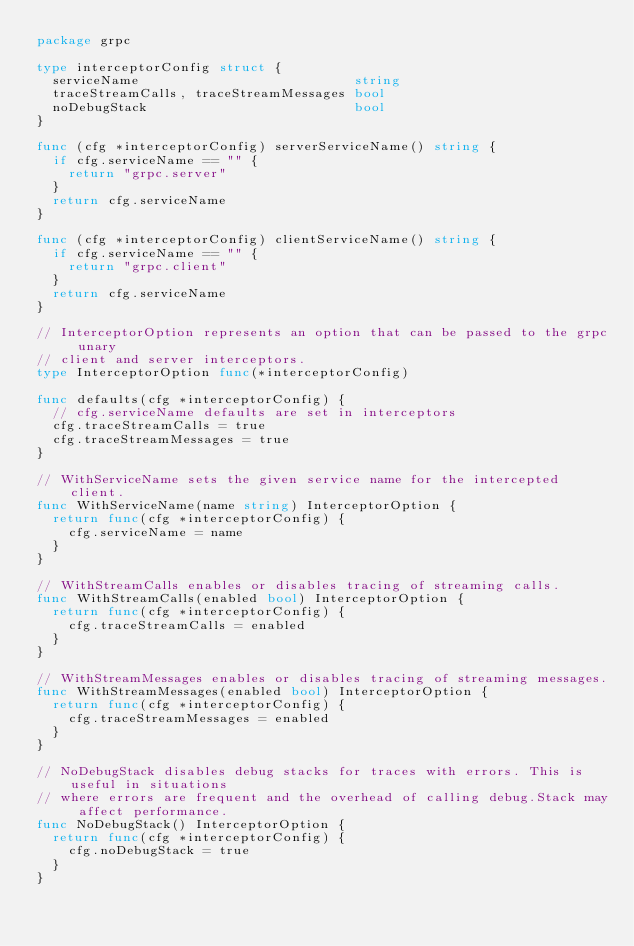<code> <loc_0><loc_0><loc_500><loc_500><_Go_>package grpc

type interceptorConfig struct {
	serviceName                           string
	traceStreamCalls, traceStreamMessages bool
	noDebugStack                          bool
}

func (cfg *interceptorConfig) serverServiceName() string {
	if cfg.serviceName == "" {
		return "grpc.server"
	}
	return cfg.serviceName
}

func (cfg *interceptorConfig) clientServiceName() string {
	if cfg.serviceName == "" {
		return "grpc.client"
	}
	return cfg.serviceName
}

// InterceptorOption represents an option that can be passed to the grpc unary
// client and server interceptors.
type InterceptorOption func(*interceptorConfig)

func defaults(cfg *interceptorConfig) {
	// cfg.serviceName defaults are set in interceptors
	cfg.traceStreamCalls = true
	cfg.traceStreamMessages = true
}

// WithServiceName sets the given service name for the intercepted client.
func WithServiceName(name string) InterceptorOption {
	return func(cfg *interceptorConfig) {
		cfg.serviceName = name
	}
}

// WithStreamCalls enables or disables tracing of streaming calls.
func WithStreamCalls(enabled bool) InterceptorOption {
	return func(cfg *interceptorConfig) {
		cfg.traceStreamCalls = enabled
	}
}

// WithStreamMessages enables or disables tracing of streaming messages.
func WithStreamMessages(enabled bool) InterceptorOption {
	return func(cfg *interceptorConfig) {
		cfg.traceStreamMessages = enabled
	}
}

// NoDebugStack disables debug stacks for traces with errors. This is useful in situations
// where errors are frequent and the overhead of calling debug.Stack may affect performance.
func NoDebugStack() InterceptorOption {
	return func(cfg *interceptorConfig) {
		cfg.noDebugStack = true
	}
}
</code> 